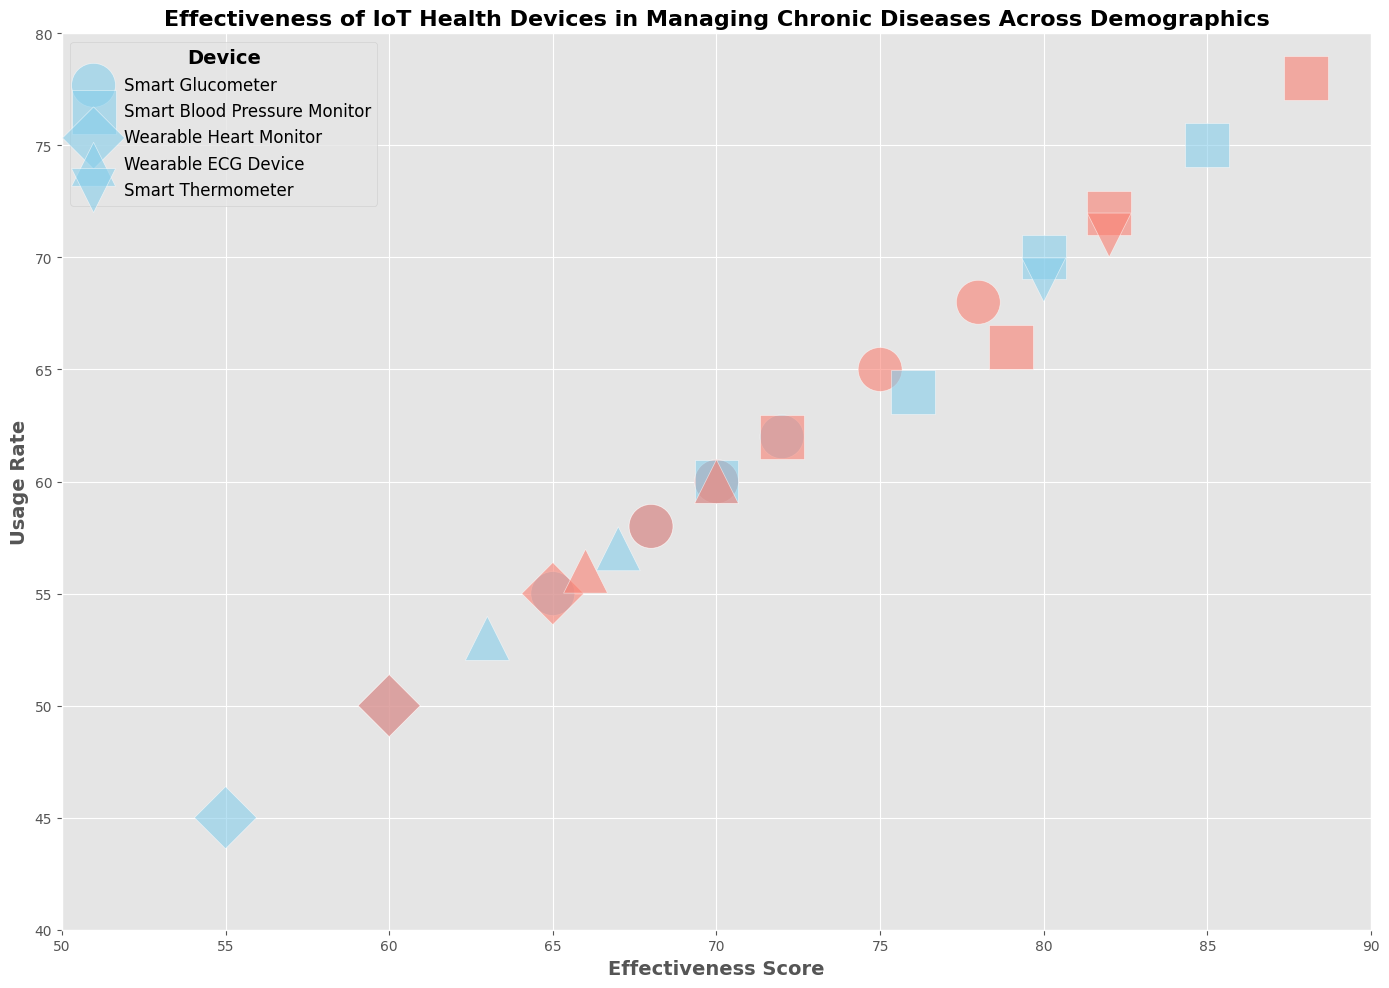Which device has the highest effectiveness score? To find the highest effectiveness score, identify the highest point on the x-axis. The Smart Blood Pressure Monitor has the highest effectiveness score with values reaching up to 88.
Answer: Smart Blood Pressure Monitor Which age group has the largest bubble size? Bubble size is represented by the age group range. The largest bubbles correspond to the age group 50-60. Both Smart Blood Pressure Monitor and Wearable Heart Monitor devices for this age group exhibit large bubble sizes.
Answer: 50-60 Compare the usage rate between males and females for the Smart Glucometer in the 30-40 age group. Look for the bubbles corresponding to the Smart Glucometer device and 30-40 age group, then compare the y-values (Usage Rate) for male and female. Female usage rate is 65, and male usage rate is 60.
Answer: Females have a higher usage rate What is the average effectiveness score of the Smart Blood Pressure Monitor across all age groups? Identify all effectiveness scores for the Smart Blood Pressure Monitor and calculate the average. The scores are 80, 82, 76, 79, 85, 88, 70, 72. Calculate (80+82+76+79+85+88+70+72)/8 = 632/8 = 79.
Answer: 79 Which gender shows higher effectiveness in using the Wearable ECG Device for the 50-60 age group? Look at the bubbles representing the Wearable ECG Device for 50-60 age group, and compare the x-values (Effectiveness Scores) for male and female. Female shows higher effectiveness with a score of 66 compared to male's 63.
Answer: Female Identify the device with the lowest usage rate for males in the 60-70 age group. Locate the bubbles corresponding to males in the 60-70 age group and find the one with the smallest y-value. The Wearable Heart Monitor has the lowest usage rate of 45.
Answer: Wearable Heart Monitor Compare the effectiveness scores of Smart Blood Pressure Monitor and Wearable Heart Monitor for the 50-60 age group. Find the bubbles corresponding to these devices in the 50-60 age group and compare their x-values (Effectiveness Scores). Smart Blood Pressure Monitor has scores of 85 and 88, while Wearable Heart Monitor has scores of 60 and 65.
Answer: Smart Blood Pressure Monitor scores higher What is the total usage rate for the Smart Glucometer among females? Sum the usage rates for all instances of females using the Smart Glucometer. The usage rates are 65, 68, 60, and 58. Calculate 65+68+60+58 = 251.
Answer: 251 